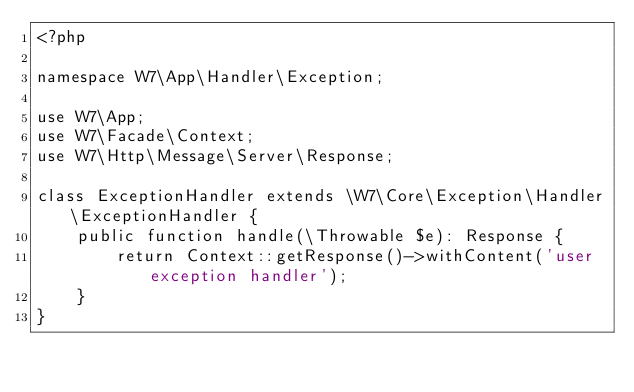Convert code to text. <code><loc_0><loc_0><loc_500><loc_500><_PHP_><?php

namespace W7\App\Handler\Exception;

use W7\App;
use W7\Facade\Context;
use W7\Http\Message\Server\Response;

class ExceptionHandler extends \W7\Core\Exception\Handler\ExceptionHandler {
	public function handle(\Throwable $e): Response {
		return Context::getResponse()->withContent('user exception handler');
	}
}</code> 